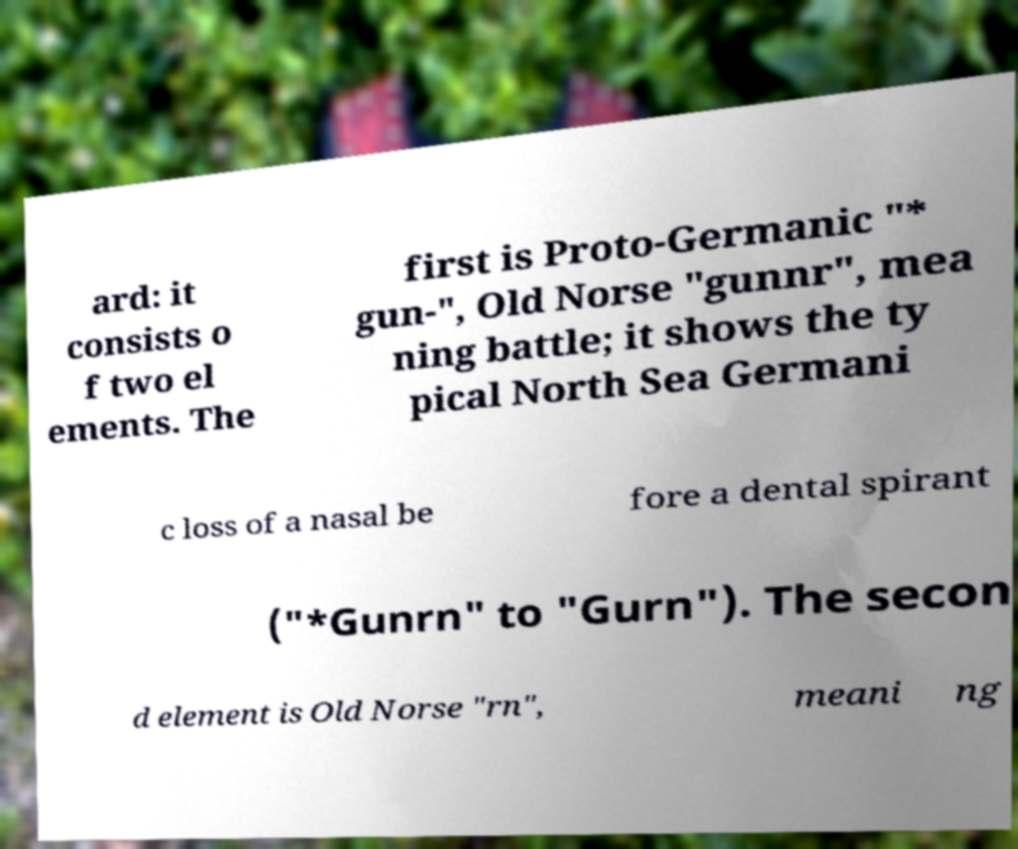There's text embedded in this image that I need extracted. Can you transcribe it verbatim? ard: it consists o f two el ements. The first is Proto-Germanic "* gun-", Old Norse "gunnr", mea ning battle; it shows the ty pical North Sea Germani c loss of a nasal be fore a dental spirant ("*Gunrn" to "Gurn"). The secon d element is Old Norse "rn", meani ng 